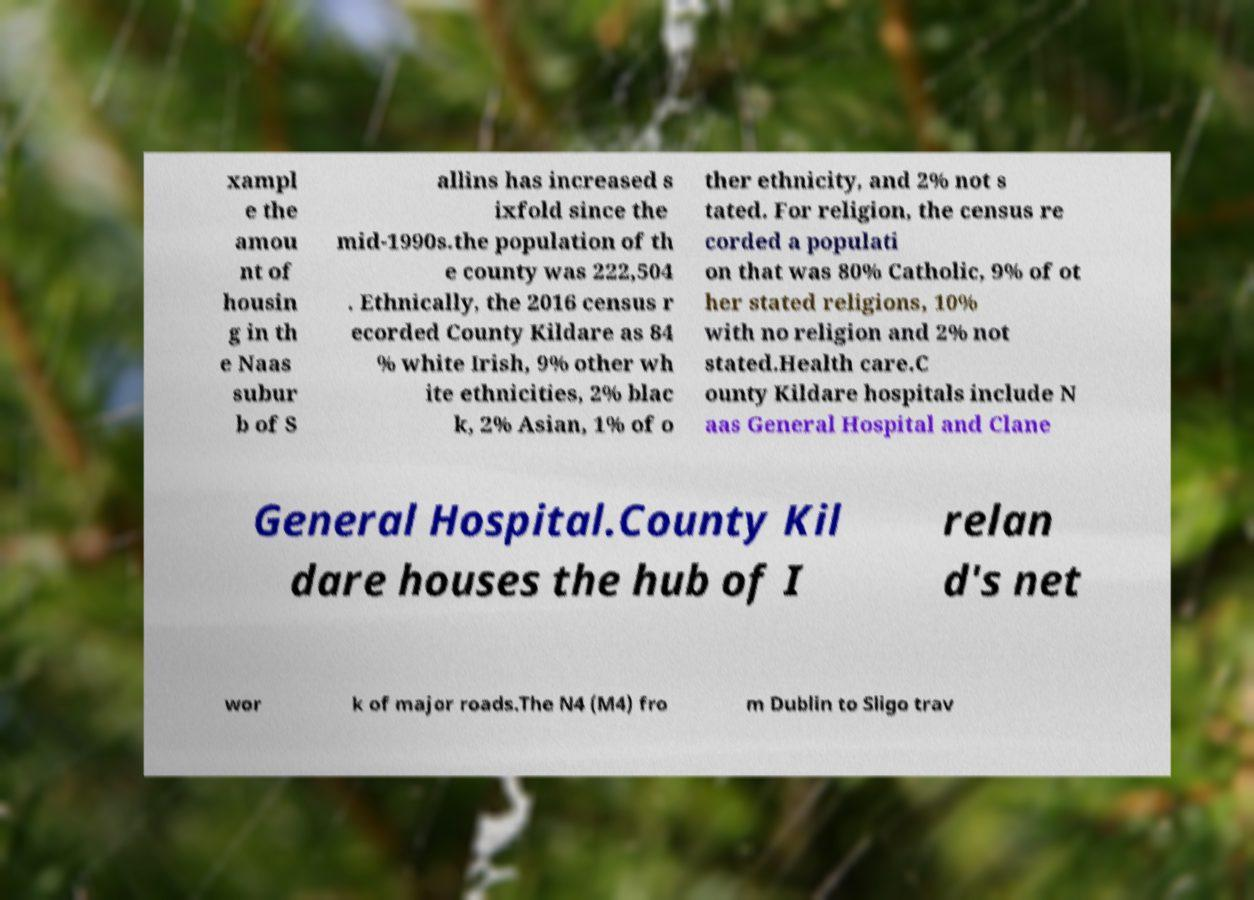Can you accurately transcribe the text from the provided image for me? xampl e the amou nt of housin g in th e Naas subur b of S allins has increased s ixfold since the mid-1990s.the population of th e county was 222,504 . Ethnically, the 2016 census r ecorded County Kildare as 84 % white Irish, 9% other wh ite ethnicities, 2% blac k, 2% Asian, 1% of o ther ethnicity, and 2% not s tated. For religion, the census re corded a populati on that was 80% Catholic, 9% of ot her stated religions, 10% with no religion and 2% not stated.Health care.C ounty Kildare hospitals include N aas General Hospital and Clane General Hospital.County Kil dare houses the hub of I relan d's net wor k of major roads.The N4 (M4) fro m Dublin to Sligo trav 